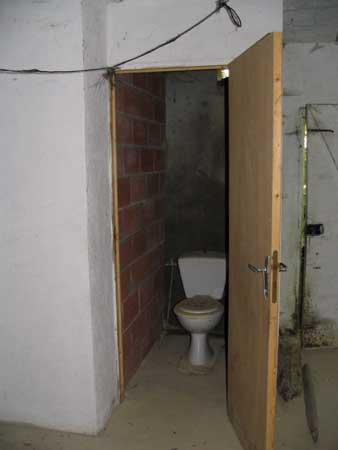Where is the toilet?
Answer briefly. Closet. Is it disgusting?
Quick response, please. Yes. Is this a large bathroom?
Concise answer only. No. How many sinks?
Write a very short answer. 0. Is the bathroom door closed?
Short answer required. No. Can you see plants in the picture?
Answer briefly. No. Is the toilet clean?
Give a very brief answer. No. Could someone see you pooping?
Be succinct. Yes. 